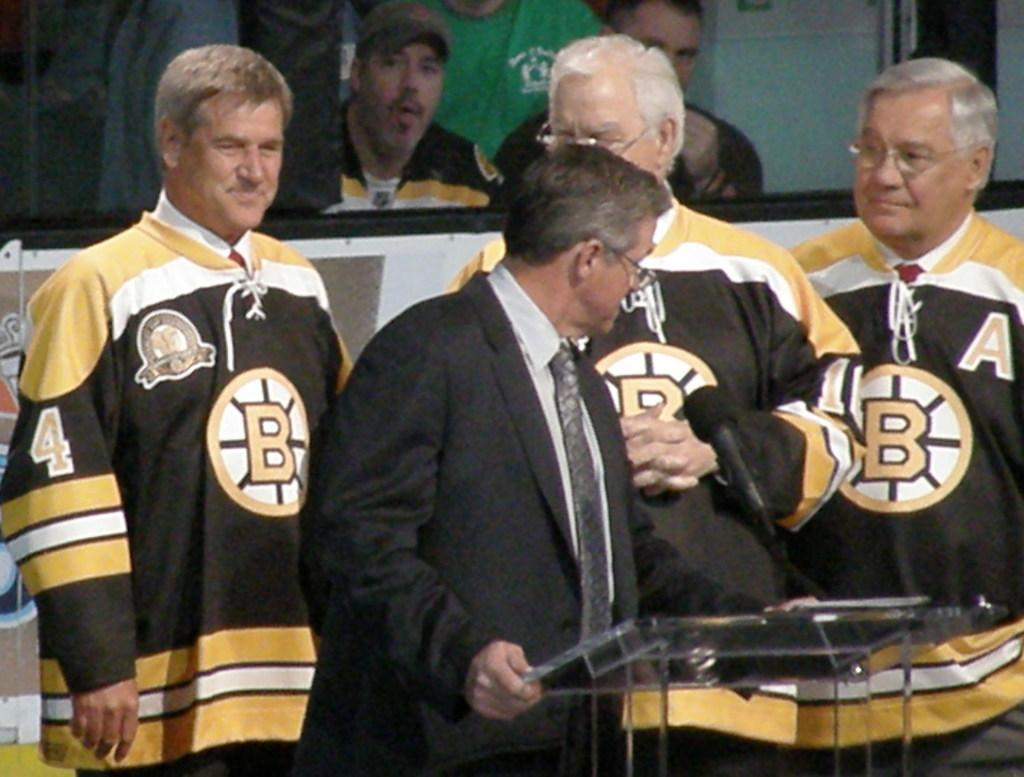<image>
Summarize the visual content of the image. men wearing a shirt with the letter B in the middle 